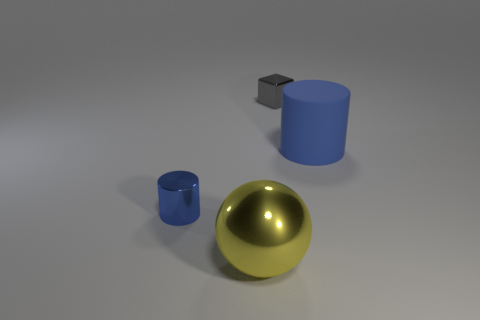What materials are the objects in the image made of, and which one looks the most reflective? The objects in the image appear to be a small metal cube, a large blue cylinder that looks like a rubber, and a gold-colored sphere. The gold-colored sphere is the most reflective, suggesting a polished metallic surface. 